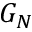Convert formula to latex. <formula><loc_0><loc_0><loc_500><loc_500>G _ { N }</formula> 